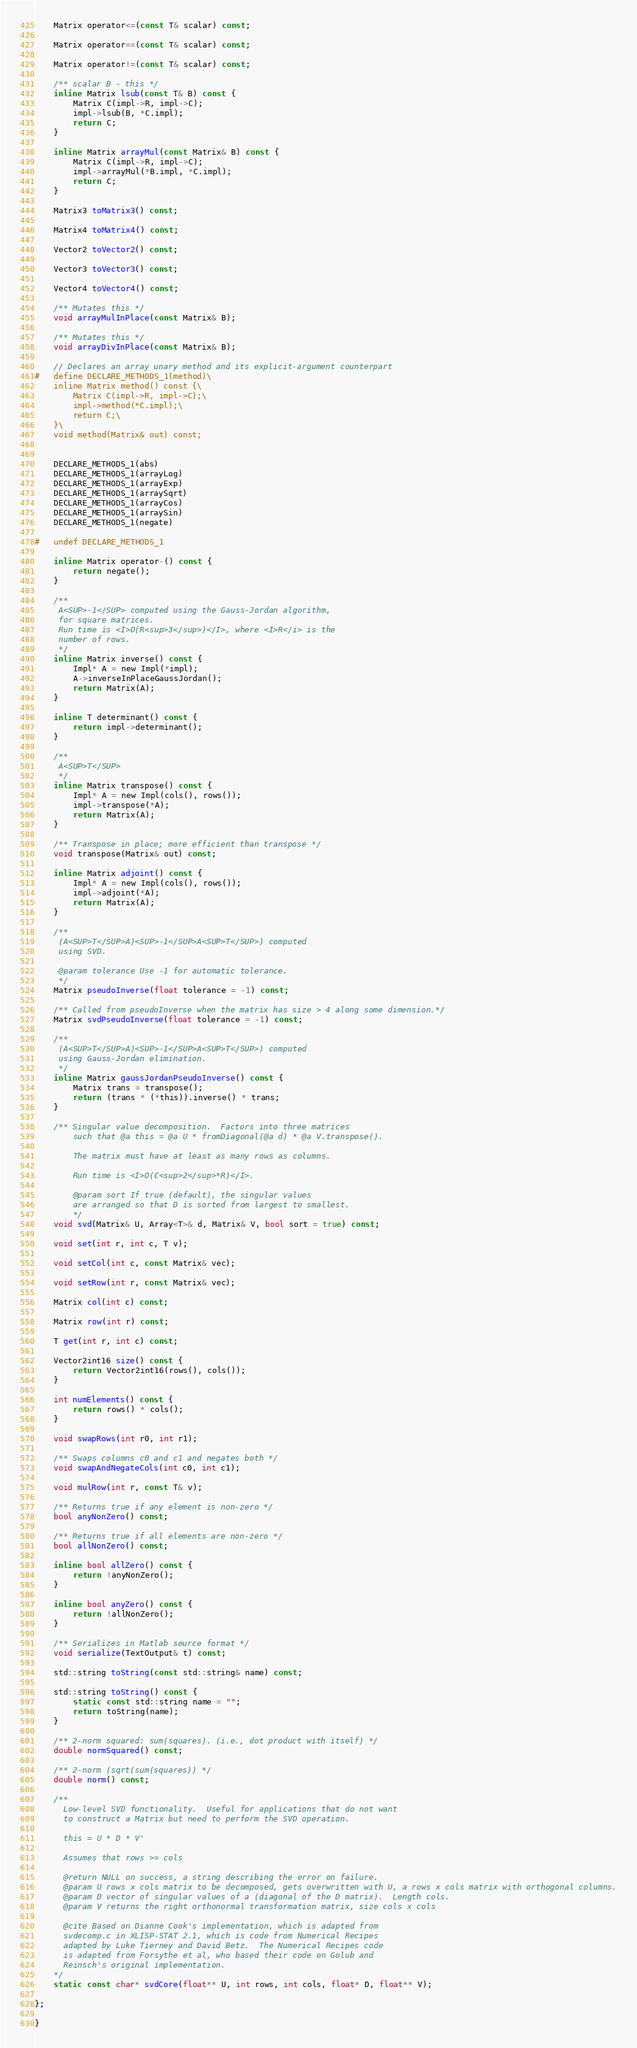Convert code to text. <code><loc_0><loc_0><loc_500><loc_500><_C_>    Matrix operator<=(const T& scalar) const;

    Matrix operator==(const T& scalar) const;

    Matrix operator!=(const T& scalar) const;

    /** scalar B - this */
    inline Matrix lsub(const T& B) const {
        Matrix C(impl->R, impl->C);
        impl->lsub(B, *C.impl);
        return C;
    }

    inline Matrix arrayMul(const Matrix& B) const {
        Matrix C(impl->R, impl->C);
        impl->arrayMul(*B.impl, *C.impl);
        return C;
    }

    Matrix3 toMatrix3() const;

    Matrix4 toMatrix4() const;
    
    Vector2 toVector2() const;

    Vector3 toVector3() const;

    Vector4 toVector4() const;

    /** Mutates this */
    void arrayMulInPlace(const Matrix& B);

    /** Mutates this */
    void arrayDivInPlace(const Matrix& B);

    // Declares an array unary method and its explicit-argument counterpart
#   define DECLARE_METHODS_1(method)\
    inline Matrix method() const {\
        Matrix C(impl->R, impl->C);\
        impl->method(*C.impl);\
        return C;\
    }\
    void method(Matrix& out) const;


    DECLARE_METHODS_1(abs)
    DECLARE_METHODS_1(arrayLog)
    DECLARE_METHODS_1(arrayExp)
    DECLARE_METHODS_1(arraySqrt)
    DECLARE_METHODS_1(arrayCos)
    DECLARE_METHODS_1(arraySin)
    DECLARE_METHODS_1(negate)

#   undef DECLARE_METHODS_1

    inline Matrix operator-() const {
        return negate();
    }

    /**
     A<SUP>-1</SUP> computed using the Gauss-Jordan algorithm,
     for square matrices.
     Run time is <I>O(R<sup>3</sup>)</I>, where <I>R</i> is the 
     number of rows.
     */
    inline Matrix inverse() const {
        Impl* A = new Impl(*impl);
        A->inverseInPlaceGaussJordan();
        return Matrix(A);
    }

    inline T determinant() const {
        return impl->determinant();
    }

    /**
     A<SUP>T</SUP>
     */
    inline Matrix transpose() const {
        Impl* A = new Impl(cols(), rows());
        impl->transpose(*A);
        return Matrix(A);
    }

    /** Transpose in place; more efficient than transpose */
    void transpose(Matrix& out) const;

    inline Matrix adjoint() const {
        Impl* A = new Impl(cols(), rows());
        impl->adjoint(*A);
        return Matrix(A);
    }

    /**     
     (A<SUP>T</SUP>A)<SUP>-1</SUP>A<SUP>T</SUP>) computed 
     using SVD.

     @param tolerance Use -1 for automatic tolerance.
     */
    Matrix pseudoInverse(float tolerance = -1) const;

    /** Called from pseudoInverse when the matrix has size > 4 along some dimension.*/
    Matrix svdPseudoInverse(float tolerance = -1) const;

    /**
     (A<SUP>T</SUP>A)<SUP>-1</SUP>A<SUP>T</SUP>) computed
     using Gauss-Jordan elimination.
     */
    inline Matrix gaussJordanPseudoInverse() const {
        Matrix trans = transpose();
        return (trans * (*this)).inverse() * trans;
    }

    /** Singular value decomposition.  Factors into three matrices 
        such that @a this = @a U * fromDiagonal(@a d) * @a V.transpose().

        The matrix must have at least as many rows as columns.
        
        Run time is <I>O(C<sup>2</sup>*R)</I>.

        @param sort If true (default), the singular values
        are arranged so that D is sorted from largest to smallest.
        */
    void svd(Matrix& U, Array<T>& d, Matrix& V, bool sort = true) const;

    void set(int r, int c, T v);

    void setCol(int c, const Matrix& vec);

    void setRow(int r, const Matrix& vec);

    Matrix col(int c) const;

    Matrix row(int r) const;

    T get(int r, int c) const;

    Vector2int16 size() const {
        return Vector2int16(rows(), cols());
    }

    int numElements() const {
        return rows() * cols();
    }

    void swapRows(int r0, int r1);

    /** Swaps columns c0 and c1 and negates both */
    void swapAndNegateCols(int c0, int c1);

    void mulRow(int r, const T& v);

    /** Returns true if any element is non-zero */
    bool anyNonZero() const;

    /** Returns true if all elements are non-zero */
    bool allNonZero() const;

    inline bool allZero() const {
        return !anyNonZero();
    }

    inline bool anyZero() const {
        return !allNonZero();
    }

    /** Serializes in Matlab source format */
    void serialize(TextOutput& t) const;

    std::string toString(const std::string& name) const;

    std::string toString() const {
        static const std::string name = "";
        return toString(name);
    }

    /** 2-norm squared: sum(squares). (i.e., dot product with itself) */
    double normSquared() const;

    /** 2-norm (sqrt(sum(squares)) */
    double norm() const;

    /**
      Low-level SVD functionality.  Useful for applications that do not want
      to construct a Matrix but need to perform the SVD operation.

      this = U * D * V'

      Assumes that rows >= cols

      @return NULL on success, a string describing the error on failure.
      @param U rows x cols matrix to be decomposed, gets overwritten with U, a rows x cols matrix with orthogonal columns.
      @param D vector of singular values of a (diagonal of the D matrix).  Length cols.
      @param V returns the right orthonormal transformation matrix, size cols x cols

      @cite Based on Dianne Cook's implementation, which is adapted from 
      svdecomp.c in XLISP-STAT 2.1, which is code from Numerical Recipes 
      adapted by Luke Tierney and David Betz.  The Numerical Recipes code 
      is adapted from Forsythe et al, who based their code on Golub and
      Reinsch's original implementation.
    */
    static const char* svdCore(float** U, int rows, int cols, float* D, float** V);

};

}
</code> 